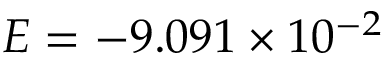<formula> <loc_0><loc_0><loc_500><loc_500>E = - 9 . 0 9 1 \times 1 0 ^ { - 2 }</formula> 